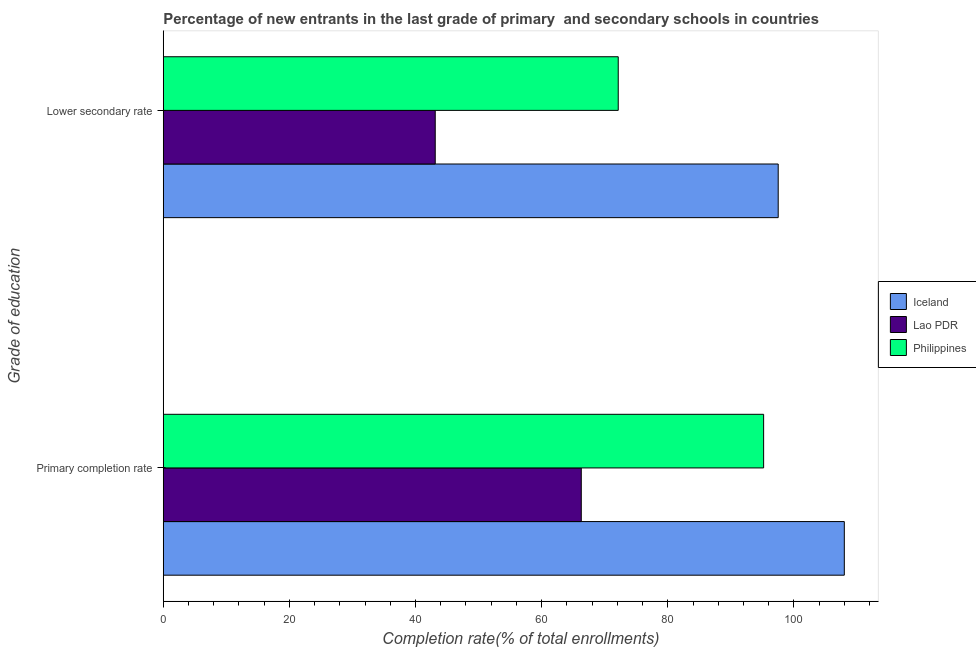How many different coloured bars are there?
Your answer should be compact. 3. Are the number of bars on each tick of the Y-axis equal?
Offer a terse response. Yes. How many bars are there on the 2nd tick from the bottom?
Your response must be concise. 3. What is the label of the 1st group of bars from the top?
Your answer should be very brief. Lower secondary rate. What is the completion rate in secondary schools in Lao PDR?
Offer a terse response. 43.13. Across all countries, what is the maximum completion rate in secondary schools?
Ensure brevity in your answer.  97.51. Across all countries, what is the minimum completion rate in secondary schools?
Offer a very short reply. 43.13. In which country was the completion rate in secondary schools maximum?
Your answer should be compact. Iceland. In which country was the completion rate in primary schools minimum?
Offer a very short reply. Lao PDR. What is the total completion rate in secondary schools in the graph?
Provide a succinct answer. 212.79. What is the difference between the completion rate in secondary schools in Iceland and that in Philippines?
Give a very brief answer. 25.37. What is the difference between the completion rate in primary schools in Iceland and the completion rate in secondary schools in Philippines?
Provide a short and direct response. 35.85. What is the average completion rate in primary schools per country?
Your answer should be compact. 89.83. What is the difference between the completion rate in secondary schools and completion rate in primary schools in Lao PDR?
Your answer should be compact. -23.16. What is the ratio of the completion rate in secondary schools in Iceland to that in Philippines?
Ensure brevity in your answer.  1.35. What does the 1st bar from the top in Lower secondary rate represents?
Ensure brevity in your answer.  Philippines. How many legend labels are there?
Ensure brevity in your answer.  3. How are the legend labels stacked?
Your answer should be very brief. Vertical. What is the title of the graph?
Provide a short and direct response. Percentage of new entrants in the last grade of primary  and secondary schools in countries. What is the label or title of the X-axis?
Provide a short and direct response. Completion rate(% of total enrollments). What is the label or title of the Y-axis?
Make the answer very short. Grade of education. What is the Completion rate(% of total enrollments) of Iceland in Primary completion rate?
Keep it short and to the point. 108. What is the Completion rate(% of total enrollments) of Lao PDR in Primary completion rate?
Your answer should be compact. 66.29. What is the Completion rate(% of total enrollments) of Philippines in Primary completion rate?
Ensure brevity in your answer.  95.2. What is the Completion rate(% of total enrollments) of Iceland in Lower secondary rate?
Your answer should be compact. 97.51. What is the Completion rate(% of total enrollments) in Lao PDR in Lower secondary rate?
Give a very brief answer. 43.13. What is the Completion rate(% of total enrollments) in Philippines in Lower secondary rate?
Offer a terse response. 72.15. Across all Grade of education, what is the maximum Completion rate(% of total enrollments) in Iceland?
Make the answer very short. 108. Across all Grade of education, what is the maximum Completion rate(% of total enrollments) of Lao PDR?
Offer a very short reply. 66.29. Across all Grade of education, what is the maximum Completion rate(% of total enrollments) in Philippines?
Keep it short and to the point. 95.2. Across all Grade of education, what is the minimum Completion rate(% of total enrollments) in Iceland?
Provide a succinct answer. 97.51. Across all Grade of education, what is the minimum Completion rate(% of total enrollments) of Lao PDR?
Offer a terse response. 43.13. Across all Grade of education, what is the minimum Completion rate(% of total enrollments) of Philippines?
Give a very brief answer. 72.15. What is the total Completion rate(% of total enrollments) of Iceland in the graph?
Your answer should be compact. 205.51. What is the total Completion rate(% of total enrollments) of Lao PDR in the graph?
Your answer should be compact. 109.41. What is the total Completion rate(% of total enrollments) in Philippines in the graph?
Offer a very short reply. 167.35. What is the difference between the Completion rate(% of total enrollments) of Iceland in Primary completion rate and that in Lower secondary rate?
Your answer should be compact. 10.48. What is the difference between the Completion rate(% of total enrollments) in Lao PDR in Primary completion rate and that in Lower secondary rate?
Make the answer very short. 23.16. What is the difference between the Completion rate(% of total enrollments) in Philippines in Primary completion rate and that in Lower secondary rate?
Offer a terse response. 23.06. What is the difference between the Completion rate(% of total enrollments) of Iceland in Primary completion rate and the Completion rate(% of total enrollments) of Lao PDR in Lower secondary rate?
Your answer should be very brief. 64.87. What is the difference between the Completion rate(% of total enrollments) of Iceland in Primary completion rate and the Completion rate(% of total enrollments) of Philippines in Lower secondary rate?
Keep it short and to the point. 35.85. What is the difference between the Completion rate(% of total enrollments) in Lao PDR in Primary completion rate and the Completion rate(% of total enrollments) in Philippines in Lower secondary rate?
Provide a succinct answer. -5.86. What is the average Completion rate(% of total enrollments) in Iceland per Grade of education?
Provide a succinct answer. 102.75. What is the average Completion rate(% of total enrollments) in Lao PDR per Grade of education?
Offer a terse response. 54.71. What is the average Completion rate(% of total enrollments) of Philippines per Grade of education?
Ensure brevity in your answer.  83.67. What is the difference between the Completion rate(% of total enrollments) in Iceland and Completion rate(% of total enrollments) in Lao PDR in Primary completion rate?
Provide a short and direct response. 41.71. What is the difference between the Completion rate(% of total enrollments) of Iceland and Completion rate(% of total enrollments) of Philippines in Primary completion rate?
Offer a very short reply. 12.79. What is the difference between the Completion rate(% of total enrollments) in Lao PDR and Completion rate(% of total enrollments) in Philippines in Primary completion rate?
Provide a succinct answer. -28.92. What is the difference between the Completion rate(% of total enrollments) of Iceland and Completion rate(% of total enrollments) of Lao PDR in Lower secondary rate?
Your answer should be compact. 54.38. What is the difference between the Completion rate(% of total enrollments) in Iceland and Completion rate(% of total enrollments) in Philippines in Lower secondary rate?
Make the answer very short. 25.37. What is the difference between the Completion rate(% of total enrollments) of Lao PDR and Completion rate(% of total enrollments) of Philippines in Lower secondary rate?
Give a very brief answer. -29.02. What is the ratio of the Completion rate(% of total enrollments) of Iceland in Primary completion rate to that in Lower secondary rate?
Provide a succinct answer. 1.11. What is the ratio of the Completion rate(% of total enrollments) in Lao PDR in Primary completion rate to that in Lower secondary rate?
Ensure brevity in your answer.  1.54. What is the ratio of the Completion rate(% of total enrollments) in Philippines in Primary completion rate to that in Lower secondary rate?
Keep it short and to the point. 1.32. What is the difference between the highest and the second highest Completion rate(% of total enrollments) of Iceland?
Keep it short and to the point. 10.48. What is the difference between the highest and the second highest Completion rate(% of total enrollments) of Lao PDR?
Make the answer very short. 23.16. What is the difference between the highest and the second highest Completion rate(% of total enrollments) of Philippines?
Offer a terse response. 23.06. What is the difference between the highest and the lowest Completion rate(% of total enrollments) of Iceland?
Keep it short and to the point. 10.48. What is the difference between the highest and the lowest Completion rate(% of total enrollments) of Lao PDR?
Offer a very short reply. 23.16. What is the difference between the highest and the lowest Completion rate(% of total enrollments) in Philippines?
Keep it short and to the point. 23.06. 